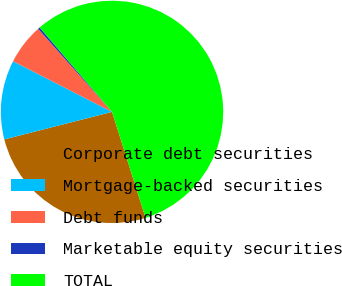Convert chart to OTSL. <chart><loc_0><loc_0><loc_500><loc_500><pie_chart><fcel>Corporate debt securities<fcel>Mortgage-backed securities<fcel>Debt funds<fcel>Marketable equity securities<fcel>TOTAL<nl><fcel>25.91%<fcel>11.51%<fcel>5.9%<fcel>0.29%<fcel>56.4%<nl></chart> 